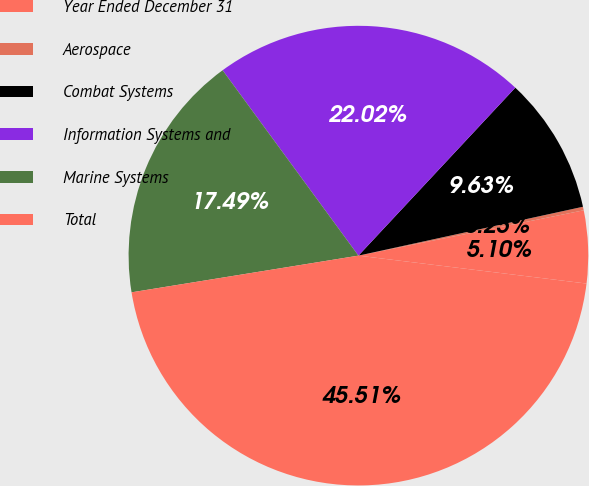Convert chart. <chart><loc_0><loc_0><loc_500><loc_500><pie_chart><fcel>Year Ended December 31<fcel>Aerospace<fcel>Combat Systems<fcel>Information Systems and<fcel>Marine Systems<fcel>Total<nl><fcel>5.1%<fcel>0.25%<fcel>9.63%<fcel>22.02%<fcel>17.49%<fcel>45.51%<nl></chart> 